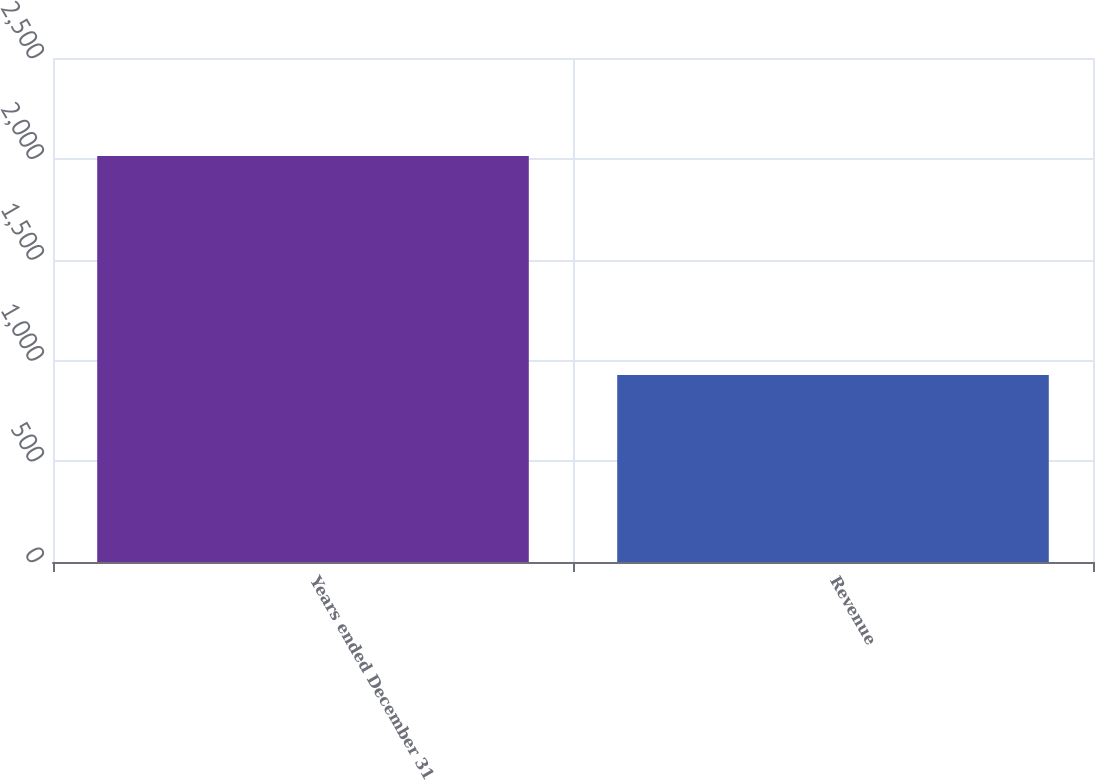<chart> <loc_0><loc_0><loc_500><loc_500><bar_chart><fcel>Years ended December 31<fcel>Revenue<nl><fcel>2014<fcel>928<nl></chart> 